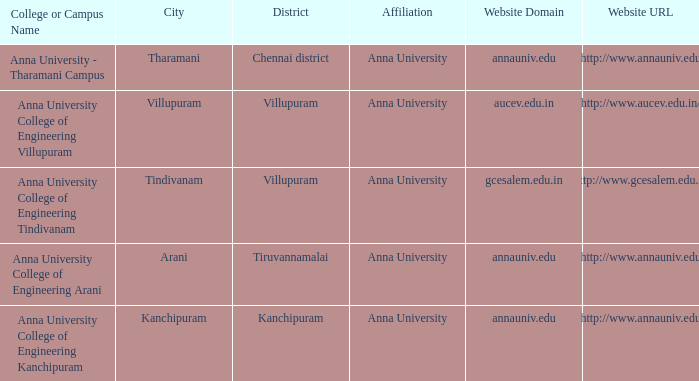What Weblink has a College or Campus Name of anna university college of engineering kanchipuram? Http://www.annauniv.edu. 